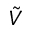<formula> <loc_0><loc_0><loc_500><loc_500>\tilde { V }</formula> 